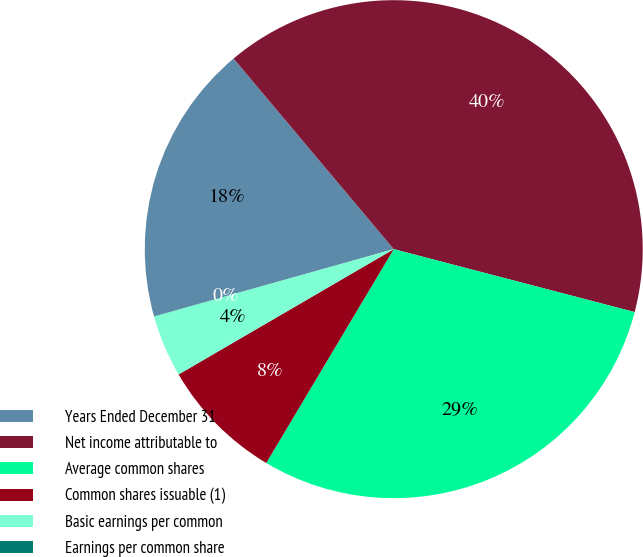Convert chart to OTSL. <chart><loc_0><loc_0><loc_500><loc_500><pie_chart><fcel>Years Ended December 31<fcel>Net income attributable to<fcel>Average common shares<fcel>Common shares issuable (1)<fcel>Basic earnings per common<fcel>Earnings per common share<nl><fcel>18.23%<fcel>40.19%<fcel>29.49%<fcel>8.05%<fcel>4.03%<fcel>0.01%<nl></chart> 